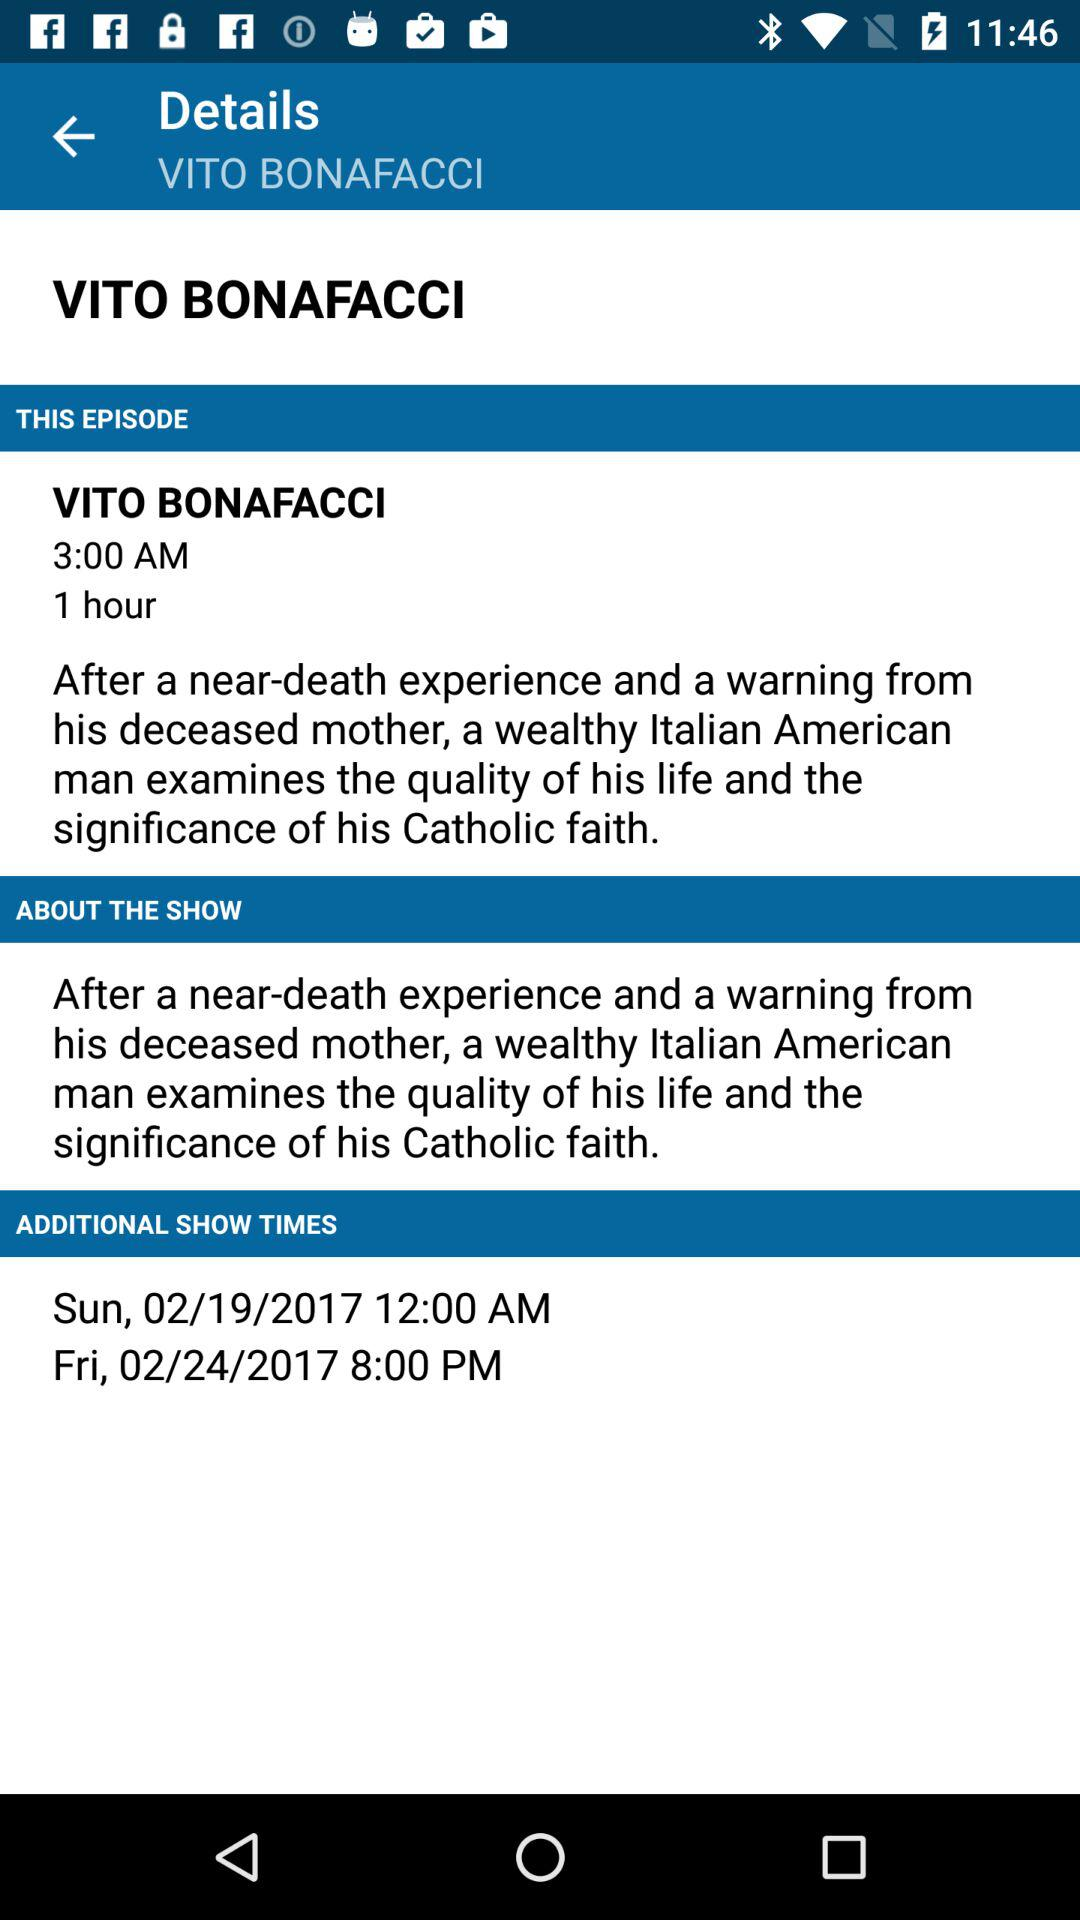What is the time duration of the episode "VITO BONAFACCI"? The time duration of the episode "VITO BONAFACCI" is 1 hour. 